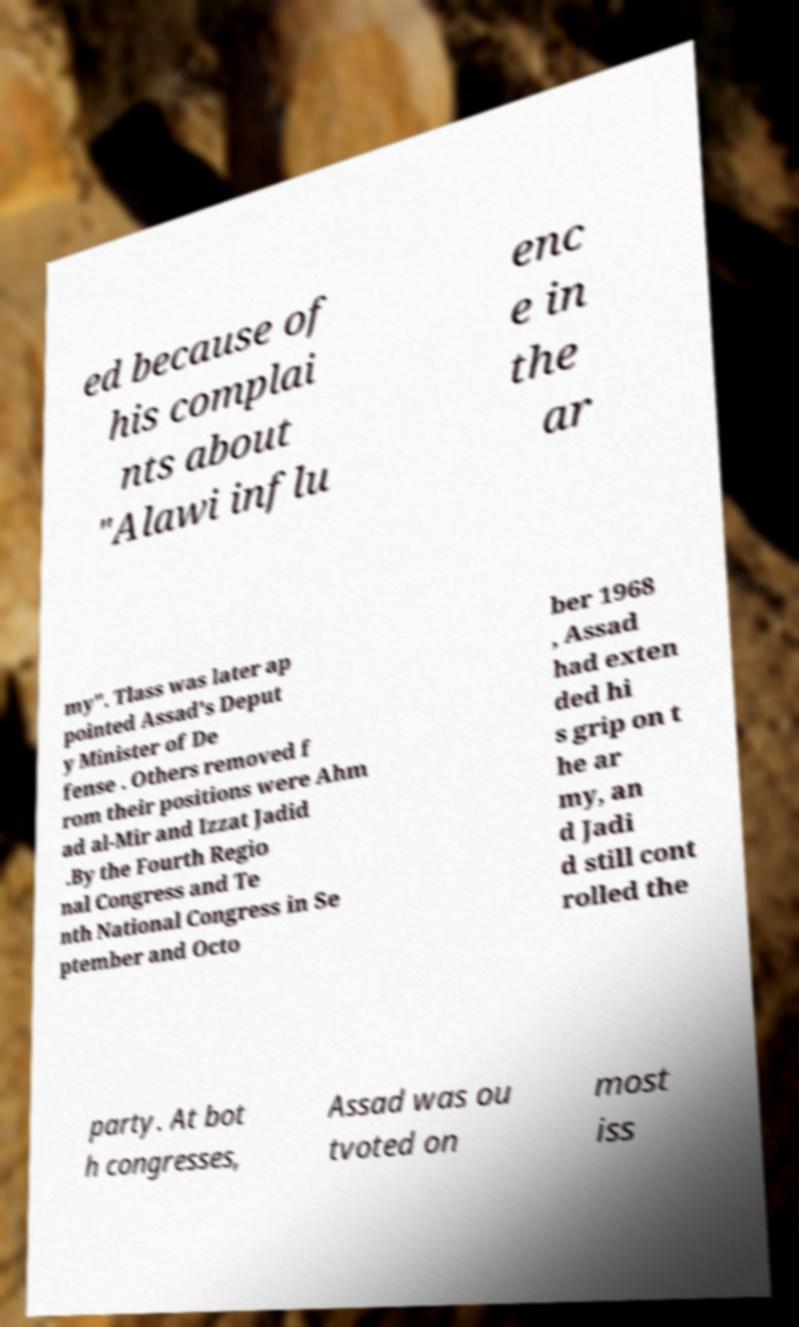For documentation purposes, I need the text within this image transcribed. Could you provide that? ed because of his complai nts about "Alawi influ enc e in the ar my". Tlass was later ap pointed Assad's Deput y Minister of De fense . Others removed f rom their positions were Ahm ad al-Mir and Izzat Jadid .By the Fourth Regio nal Congress and Te nth National Congress in Se ptember and Octo ber 1968 , Assad had exten ded hi s grip on t he ar my, an d Jadi d still cont rolled the party. At bot h congresses, Assad was ou tvoted on most iss 